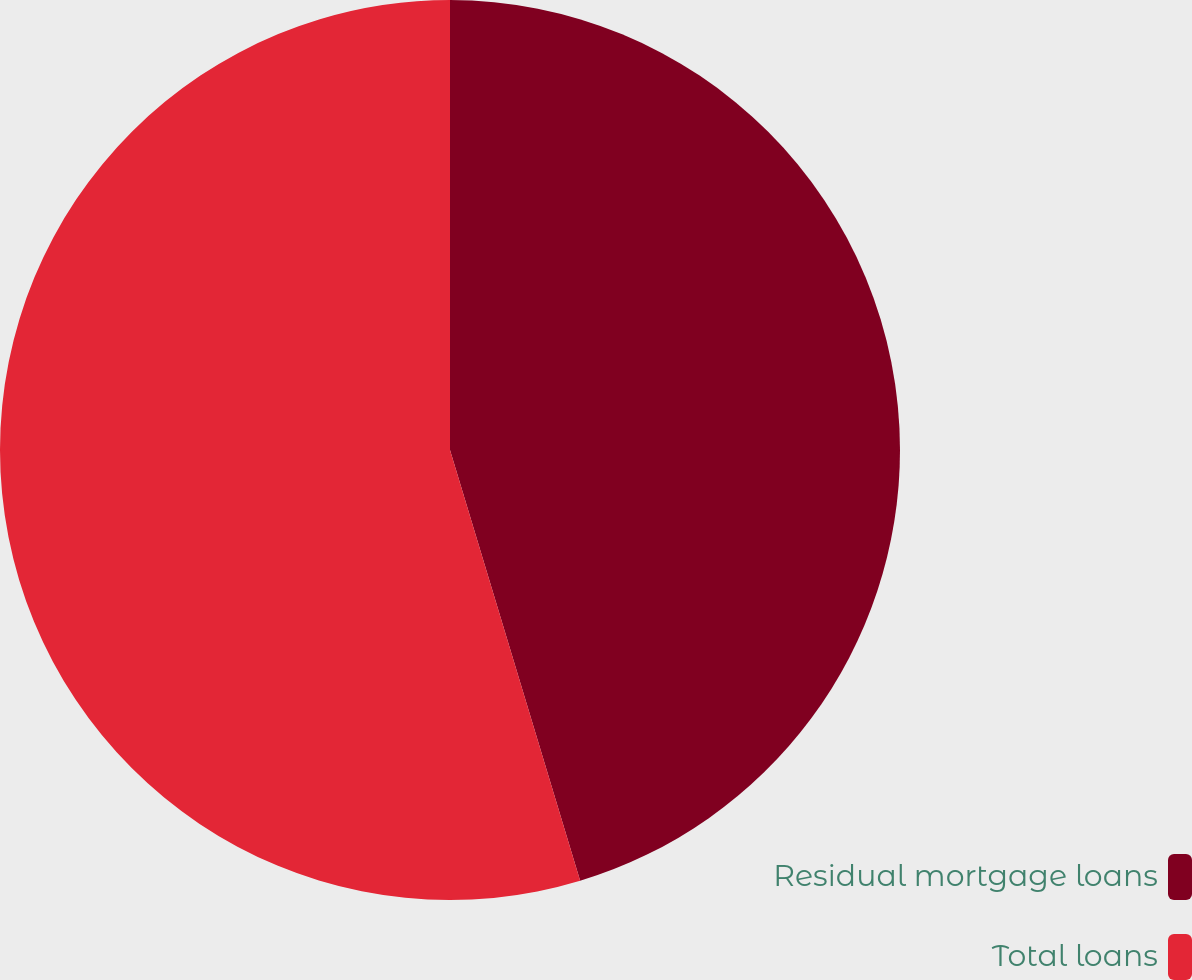Convert chart to OTSL. <chart><loc_0><loc_0><loc_500><loc_500><pie_chart><fcel>Residual mortgage loans<fcel>Total loans<nl><fcel>45.33%<fcel>54.67%<nl></chart> 